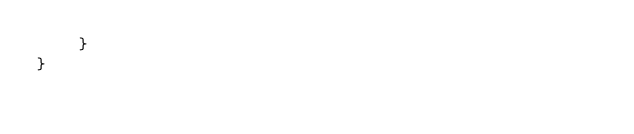<code> <loc_0><loc_0><loc_500><loc_500><_C#_>    }
}
</code> 